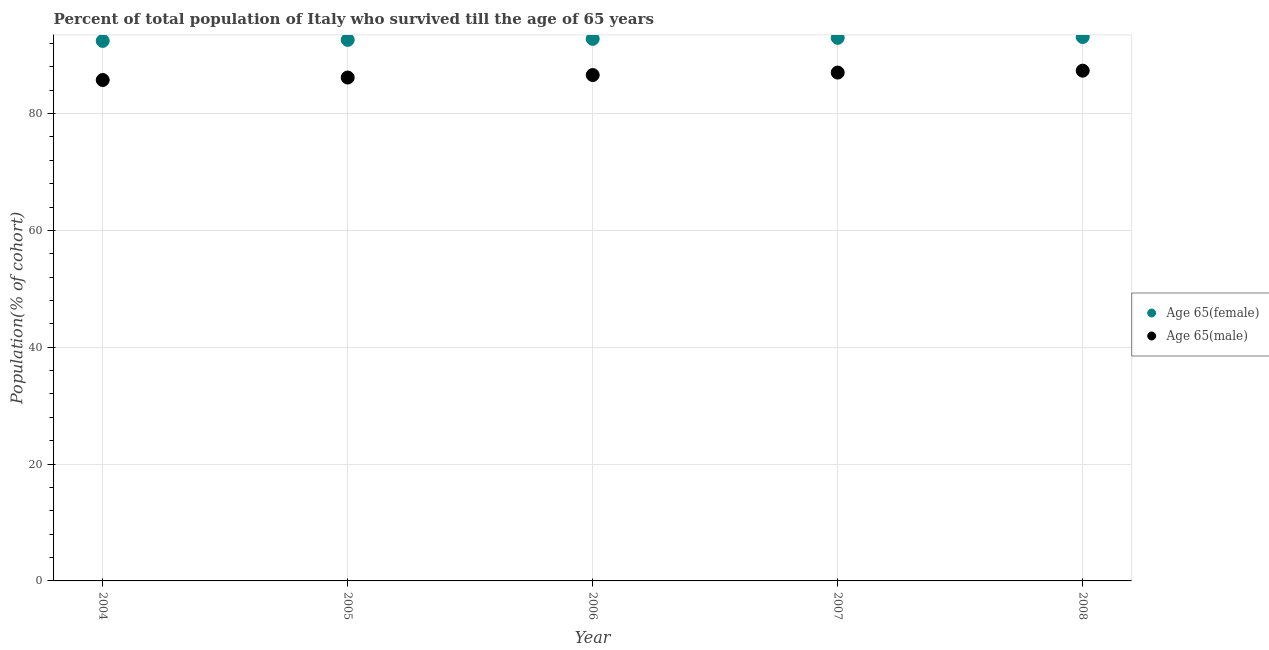What is the percentage of female population who survived till age of 65 in 2004?
Make the answer very short. 92.45. Across all years, what is the maximum percentage of female population who survived till age of 65?
Your response must be concise. 93.11. Across all years, what is the minimum percentage of male population who survived till age of 65?
Make the answer very short. 85.75. In which year was the percentage of male population who survived till age of 65 minimum?
Provide a short and direct response. 2004. What is the total percentage of male population who survived till age of 65 in the graph?
Make the answer very short. 432.91. What is the difference between the percentage of male population who survived till age of 65 in 2006 and that in 2007?
Give a very brief answer. -0.42. What is the difference between the percentage of male population who survived till age of 65 in 2007 and the percentage of female population who survived till age of 65 in 2006?
Offer a very short reply. -5.77. What is the average percentage of male population who survived till age of 65 per year?
Offer a terse response. 86.58. In the year 2007, what is the difference between the percentage of male population who survived till age of 65 and percentage of female population who survived till age of 65?
Your answer should be compact. -5.95. In how many years, is the percentage of female population who survived till age of 65 greater than 60 %?
Keep it short and to the point. 5. What is the ratio of the percentage of male population who survived till age of 65 in 2006 to that in 2007?
Your answer should be very brief. 1. What is the difference between the highest and the second highest percentage of male population who survived till age of 65?
Your answer should be very brief. 0.32. What is the difference between the highest and the lowest percentage of female population who survived till age of 65?
Give a very brief answer. 0.67. Is the sum of the percentage of male population who survived till age of 65 in 2004 and 2005 greater than the maximum percentage of female population who survived till age of 65 across all years?
Offer a very short reply. Yes. What is the difference between two consecutive major ticks on the Y-axis?
Offer a terse response. 20. Does the graph contain any zero values?
Keep it short and to the point. No. Does the graph contain grids?
Give a very brief answer. Yes. Where does the legend appear in the graph?
Offer a terse response. Center right. How many legend labels are there?
Provide a succinct answer. 2. How are the legend labels stacked?
Offer a terse response. Vertical. What is the title of the graph?
Keep it short and to the point. Percent of total population of Italy who survived till the age of 65 years. What is the label or title of the X-axis?
Your response must be concise. Year. What is the label or title of the Y-axis?
Provide a short and direct response. Population(% of cohort). What is the Population(% of cohort) in Age 65(female) in 2004?
Offer a terse response. 92.45. What is the Population(% of cohort) in Age 65(male) in 2004?
Keep it short and to the point. 85.75. What is the Population(% of cohort) in Age 65(female) in 2005?
Offer a very short reply. 92.62. What is the Population(% of cohort) in Age 65(male) in 2005?
Provide a succinct answer. 86.18. What is the Population(% of cohort) of Age 65(female) in 2006?
Your answer should be very brief. 92.8. What is the Population(% of cohort) of Age 65(male) in 2006?
Make the answer very short. 86.6. What is the Population(% of cohort) in Age 65(female) in 2007?
Your answer should be very brief. 92.97. What is the Population(% of cohort) in Age 65(male) in 2007?
Make the answer very short. 87.03. What is the Population(% of cohort) of Age 65(female) in 2008?
Keep it short and to the point. 93.11. What is the Population(% of cohort) in Age 65(male) in 2008?
Provide a short and direct response. 87.35. Across all years, what is the maximum Population(% of cohort) of Age 65(female)?
Ensure brevity in your answer.  93.11. Across all years, what is the maximum Population(% of cohort) in Age 65(male)?
Make the answer very short. 87.35. Across all years, what is the minimum Population(% of cohort) of Age 65(female)?
Offer a terse response. 92.45. Across all years, what is the minimum Population(% of cohort) of Age 65(male)?
Ensure brevity in your answer.  85.75. What is the total Population(% of cohort) in Age 65(female) in the graph?
Offer a terse response. 463.95. What is the total Population(% of cohort) of Age 65(male) in the graph?
Your answer should be compact. 432.91. What is the difference between the Population(% of cohort) in Age 65(female) in 2004 and that in 2005?
Give a very brief answer. -0.18. What is the difference between the Population(% of cohort) of Age 65(male) in 2004 and that in 2005?
Provide a succinct answer. -0.42. What is the difference between the Population(% of cohort) in Age 65(female) in 2004 and that in 2006?
Give a very brief answer. -0.35. What is the difference between the Population(% of cohort) in Age 65(male) in 2004 and that in 2006?
Give a very brief answer. -0.85. What is the difference between the Population(% of cohort) in Age 65(female) in 2004 and that in 2007?
Give a very brief answer. -0.53. What is the difference between the Population(% of cohort) in Age 65(male) in 2004 and that in 2007?
Provide a succinct answer. -1.27. What is the difference between the Population(% of cohort) in Age 65(female) in 2004 and that in 2008?
Give a very brief answer. -0.67. What is the difference between the Population(% of cohort) in Age 65(male) in 2004 and that in 2008?
Provide a succinct answer. -1.6. What is the difference between the Population(% of cohort) of Age 65(female) in 2005 and that in 2006?
Your answer should be very brief. -0.18. What is the difference between the Population(% of cohort) in Age 65(male) in 2005 and that in 2006?
Provide a short and direct response. -0.42. What is the difference between the Population(% of cohort) of Age 65(female) in 2005 and that in 2007?
Ensure brevity in your answer.  -0.35. What is the difference between the Population(% of cohort) of Age 65(male) in 2005 and that in 2007?
Offer a very short reply. -0.85. What is the difference between the Population(% of cohort) of Age 65(female) in 2005 and that in 2008?
Offer a terse response. -0.49. What is the difference between the Population(% of cohort) of Age 65(male) in 2005 and that in 2008?
Your answer should be very brief. -1.17. What is the difference between the Population(% of cohort) in Age 65(female) in 2006 and that in 2007?
Keep it short and to the point. -0.18. What is the difference between the Population(% of cohort) in Age 65(male) in 2006 and that in 2007?
Your response must be concise. -0.42. What is the difference between the Population(% of cohort) in Age 65(female) in 2006 and that in 2008?
Give a very brief answer. -0.32. What is the difference between the Population(% of cohort) in Age 65(male) in 2006 and that in 2008?
Make the answer very short. -0.75. What is the difference between the Population(% of cohort) in Age 65(female) in 2007 and that in 2008?
Ensure brevity in your answer.  -0.14. What is the difference between the Population(% of cohort) in Age 65(male) in 2007 and that in 2008?
Your answer should be compact. -0.32. What is the difference between the Population(% of cohort) in Age 65(female) in 2004 and the Population(% of cohort) in Age 65(male) in 2005?
Offer a terse response. 6.27. What is the difference between the Population(% of cohort) of Age 65(female) in 2004 and the Population(% of cohort) of Age 65(male) in 2006?
Your answer should be compact. 5.84. What is the difference between the Population(% of cohort) of Age 65(female) in 2004 and the Population(% of cohort) of Age 65(male) in 2007?
Your answer should be compact. 5.42. What is the difference between the Population(% of cohort) of Age 65(female) in 2004 and the Population(% of cohort) of Age 65(male) in 2008?
Your answer should be compact. 5.09. What is the difference between the Population(% of cohort) in Age 65(female) in 2005 and the Population(% of cohort) in Age 65(male) in 2006?
Keep it short and to the point. 6.02. What is the difference between the Population(% of cohort) of Age 65(female) in 2005 and the Population(% of cohort) of Age 65(male) in 2007?
Offer a terse response. 5.59. What is the difference between the Population(% of cohort) of Age 65(female) in 2005 and the Population(% of cohort) of Age 65(male) in 2008?
Your answer should be compact. 5.27. What is the difference between the Population(% of cohort) in Age 65(female) in 2006 and the Population(% of cohort) in Age 65(male) in 2007?
Keep it short and to the point. 5.77. What is the difference between the Population(% of cohort) in Age 65(female) in 2006 and the Population(% of cohort) in Age 65(male) in 2008?
Provide a succinct answer. 5.45. What is the difference between the Population(% of cohort) of Age 65(female) in 2007 and the Population(% of cohort) of Age 65(male) in 2008?
Ensure brevity in your answer.  5.62. What is the average Population(% of cohort) of Age 65(female) per year?
Your response must be concise. 92.79. What is the average Population(% of cohort) in Age 65(male) per year?
Offer a terse response. 86.58. In the year 2004, what is the difference between the Population(% of cohort) of Age 65(female) and Population(% of cohort) of Age 65(male)?
Ensure brevity in your answer.  6.69. In the year 2005, what is the difference between the Population(% of cohort) of Age 65(female) and Population(% of cohort) of Age 65(male)?
Your response must be concise. 6.44. In the year 2006, what is the difference between the Population(% of cohort) in Age 65(female) and Population(% of cohort) in Age 65(male)?
Provide a short and direct response. 6.19. In the year 2007, what is the difference between the Population(% of cohort) of Age 65(female) and Population(% of cohort) of Age 65(male)?
Your answer should be compact. 5.95. In the year 2008, what is the difference between the Population(% of cohort) in Age 65(female) and Population(% of cohort) in Age 65(male)?
Make the answer very short. 5.76. What is the ratio of the Population(% of cohort) in Age 65(male) in 2004 to that in 2006?
Ensure brevity in your answer.  0.99. What is the ratio of the Population(% of cohort) of Age 65(male) in 2004 to that in 2007?
Make the answer very short. 0.99. What is the ratio of the Population(% of cohort) of Age 65(female) in 2004 to that in 2008?
Your answer should be very brief. 0.99. What is the ratio of the Population(% of cohort) in Age 65(male) in 2004 to that in 2008?
Give a very brief answer. 0.98. What is the ratio of the Population(% of cohort) in Age 65(male) in 2005 to that in 2007?
Provide a short and direct response. 0.99. What is the ratio of the Population(% of cohort) of Age 65(female) in 2005 to that in 2008?
Offer a terse response. 0.99. What is the ratio of the Population(% of cohort) of Age 65(male) in 2005 to that in 2008?
Keep it short and to the point. 0.99. What is the ratio of the Population(% of cohort) in Age 65(female) in 2006 to that in 2008?
Your answer should be compact. 1. What is the difference between the highest and the second highest Population(% of cohort) in Age 65(female)?
Your answer should be compact. 0.14. What is the difference between the highest and the second highest Population(% of cohort) in Age 65(male)?
Your response must be concise. 0.32. What is the difference between the highest and the lowest Population(% of cohort) of Age 65(female)?
Your answer should be very brief. 0.67. What is the difference between the highest and the lowest Population(% of cohort) in Age 65(male)?
Offer a terse response. 1.6. 